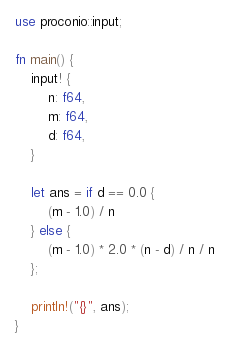Convert code to text. <code><loc_0><loc_0><loc_500><loc_500><_Rust_>use proconio::input;

fn main() {
    input! {
        n: f64,
        m: f64,
        d: f64,
    }

    let ans = if d == 0.0 {
        (m - 1.0) / n
    } else {
        (m - 1.0) * 2.0 * (n - d) / n / n
    };

    println!("{}", ans);
}
</code> 